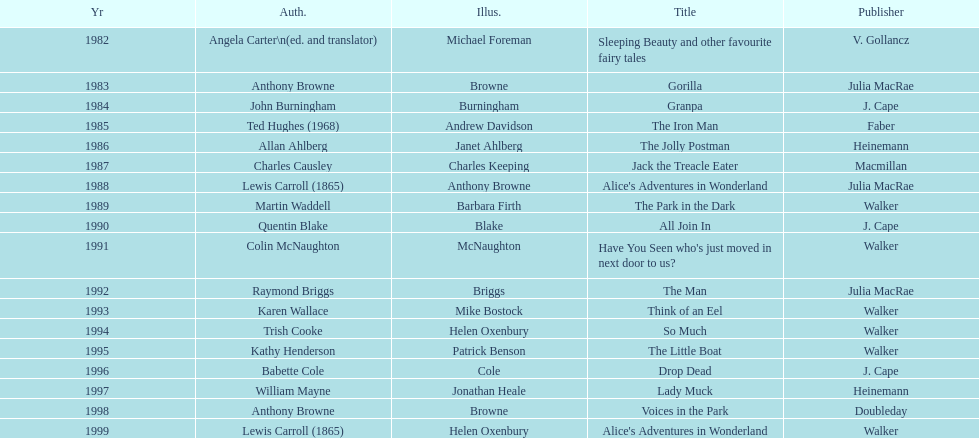How many titles did walker publish? 6. 